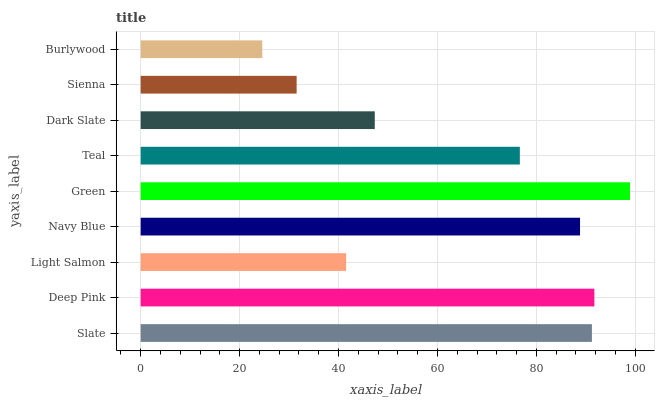Is Burlywood the minimum?
Answer yes or no. Yes. Is Green the maximum?
Answer yes or no. Yes. Is Deep Pink the minimum?
Answer yes or no. No. Is Deep Pink the maximum?
Answer yes or no. No. Is Deep Pink greater than Slate?
Answer yes or no. Yes. Is Slate less than Deep Pink?
Answer yes or no. Yes. Is Slate greater than Deep Pink?
Answer yes or no. No. Is Deep Pink less than Slate?
Answer yes or no. No. Is Teal the high median?
Answer yes or no. Yes. Is Teal the low median?
Answer yes or no. Yes. Is Dark Slate the high median?
Answer yes or no. No. Is Light Salmon the low median?
Answer yes or no. No. 